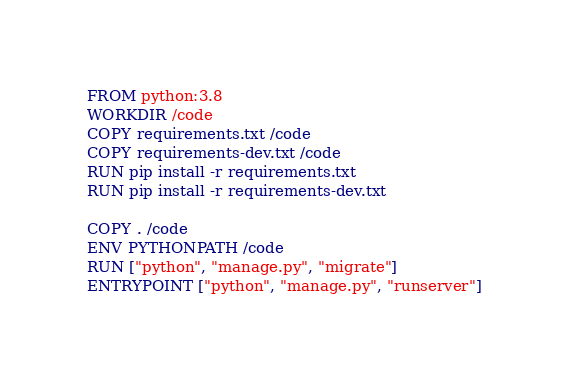Convert code to text. <code><loc_0><loc_0><loc_500><loc_500><_Dockerfile_>FROM python:3.8
WORKDIR /code
COPY requirements.txt /code
COPY requirements-dev.txt /code
RUN pip install -r requirements.txt
RUN pip install -r requirements-dev.txt

COPY . /code
ENV PYTHONPATH /code
RUN ["python", "manage.py", "migrate"]
ENTRYPOINT ["python", "manage.py", "runserver"]
</code> 